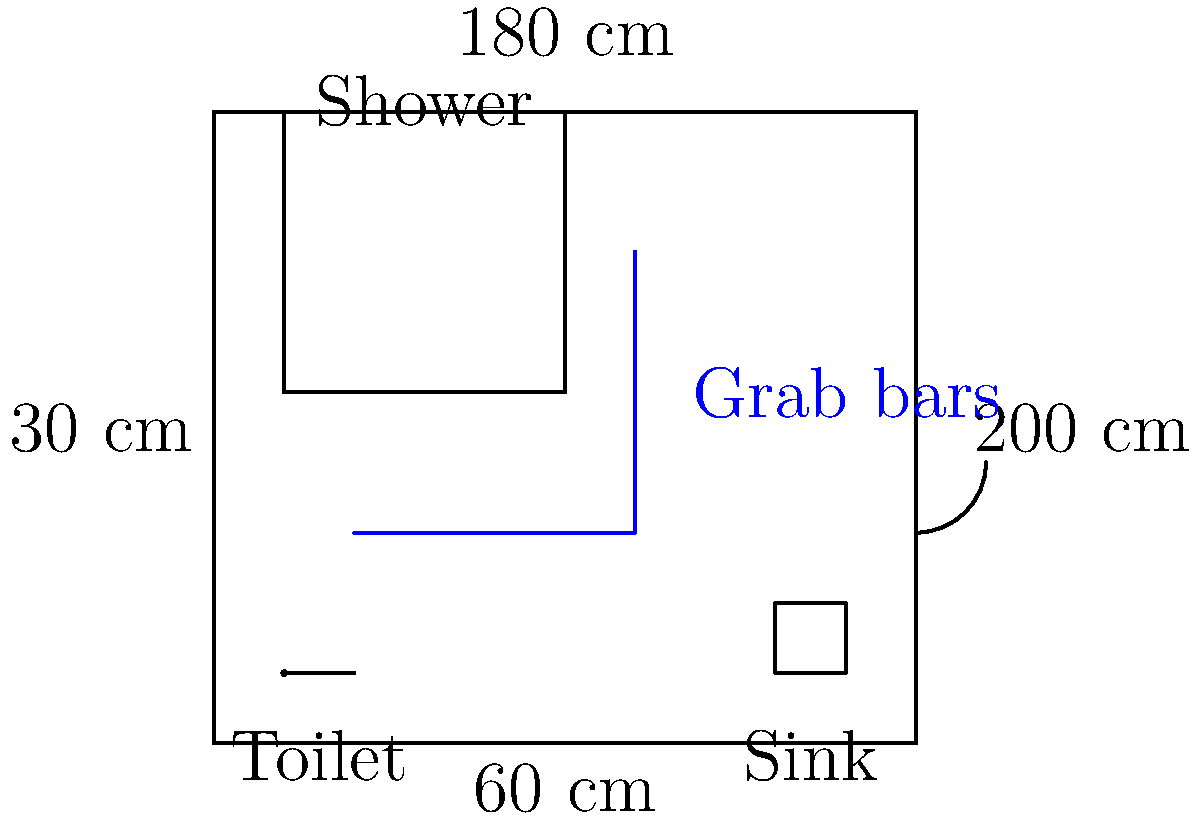Based on the accessible bathroom layout shown, what is the minimum clear floor space required in front of the toilet for individuals with limb loss to maneuver a wheelchair or use assistive devices? To determine the minimum clear floor space required in front of the toilet for individuals with limb loss, we need to consider the following steps:

1. Identify the toilet location in the layout.
2. Measure the space in front of the toilet.
3. Consider accessibility guidelines for wheelchair users and individuals with limb loss.

Step 1: The toilet is located in the bottom left corner of the bathroom layout.

Step 2: Measuring the space in front of the toilet, we can see that there is a clear area extending from the toilet to the grab bar.

Step 3: According to accessibility guidelines:
- A minimum clear floor space of 60 cm x 120 cm (24 inches x 48 inches) is typically required in front of the toilet for wheelchair users.
- For individuals with limb loss, additional space may be beneficial for maneuvering assistive devices or prosthetics.

In this layout, we can see that the clear floor space in front of the toilet extends beyond the minimum requirements. The space appears to be approximately 120 cm x 120 cm (48 inches x 48 inches), which provides ample room for wheelchair users and individuals with limb loss to maneuver and transfer safely.

This larger clear floor space accommodates various transfer techniques, the use of assistive devices, and allows for a caregiver to assist if necessary.
Answer: 120 cm x 120 cm (48 inches x 48 inches) 